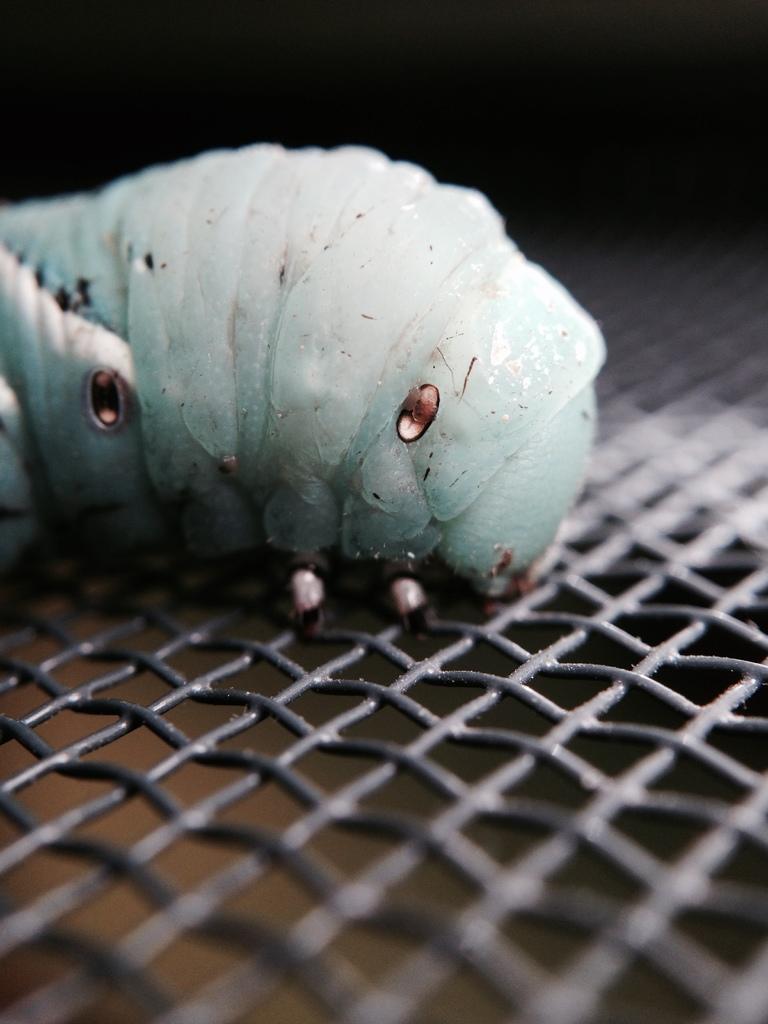In one or two sentences, can you explain what this image depicts? In the picture there is a horn worm on a mesh. 